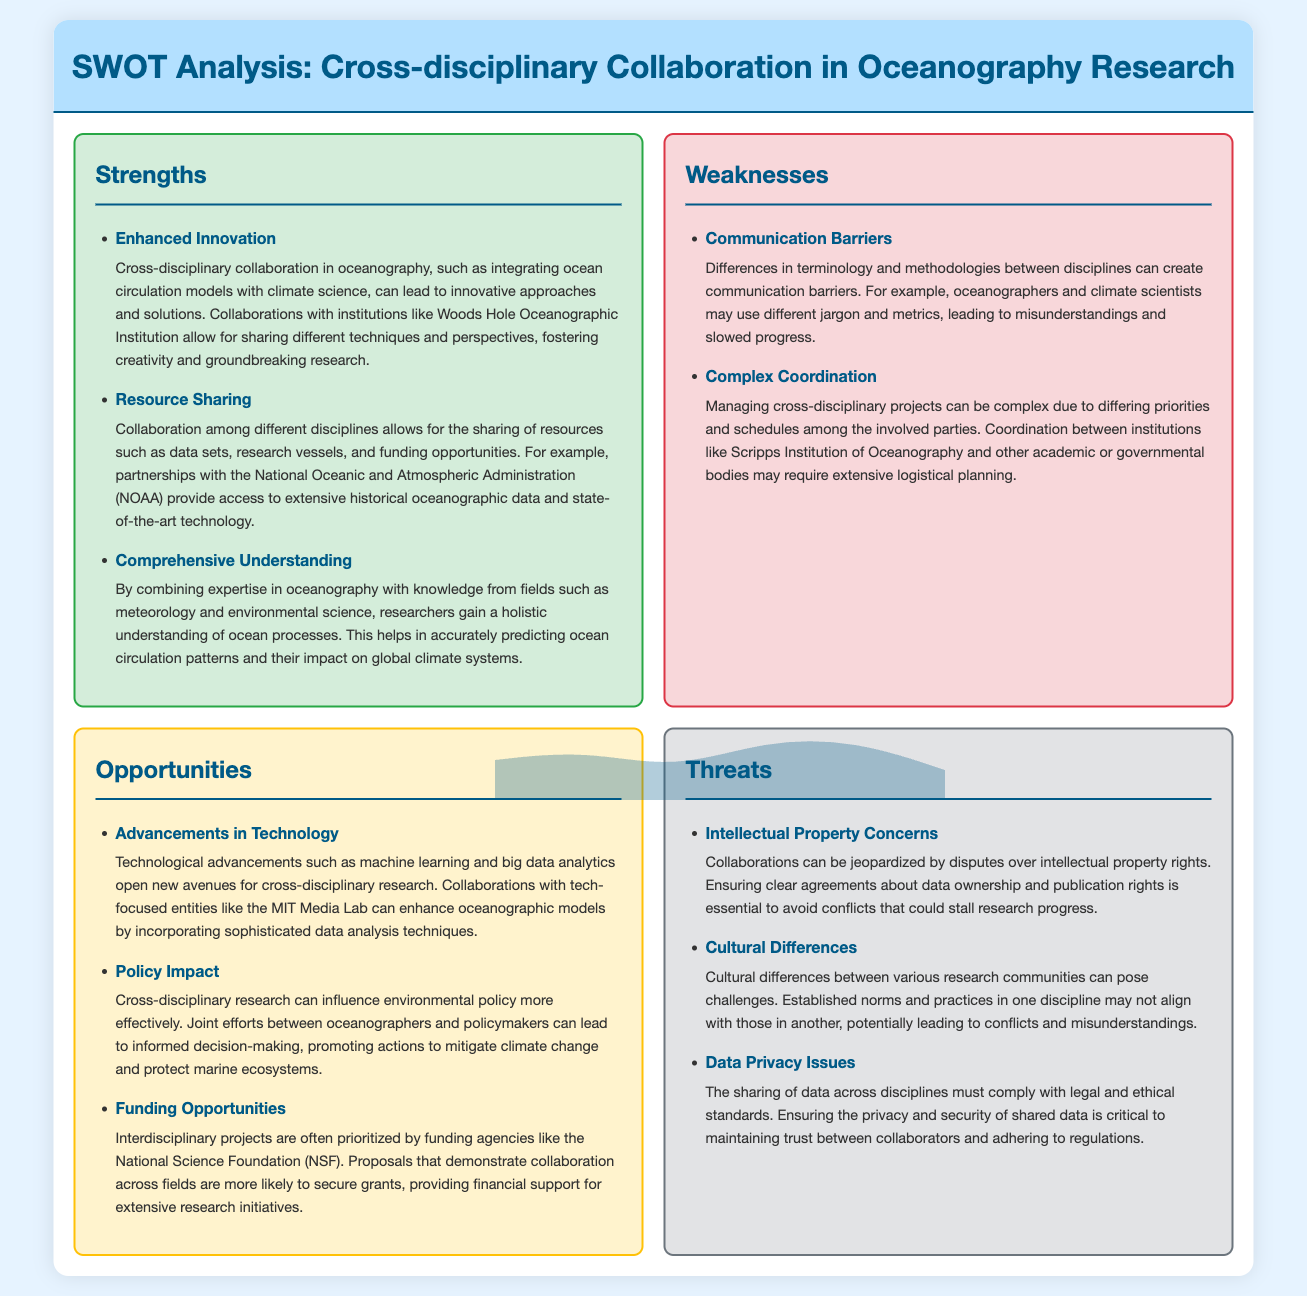what is one strength of cross-disciplinary collaboration in oceanography? The document states that "Enhanced Innovation" is a strength, emphasizing innovative approaches and solutions that arise from collaboration.
Answer: Enhanced Innovation what is a weakness mentioned in the analysis? One weakness highlighted is "Communication Barriers," which discusses how differing terminologies can impede understanding.
Answer: Communication Barriers which institution is mentioned as a collaborator for data sharing? The National Oceanic and Atmospheric Administration (NOAA) is mentioned as a partner providing access to data resources.
Answer: NOAA what is one opportunity for oceanography research through cross-disciplinary collaboration? The document describes "Advancements in Technology" as an opportunity, particularly mentioning machine learning and big data analytics.
Answer: Advancements in Technology what is a threat related to data in cross-disciplinary research? "Data Privacy Issues" is a threat noted in the document, highlighting the importance of compliance with legal standards.
Answer: Data Privacy Issues how many strengths are listed in the SWOT analysis? There are three strengths listed in the analysis that pertain to cross-disciplinary collaboration.
Answer: 3 which two institutions are referenced regarding complex coordination in projects? The document specifically mentions Scripps Institution of Oceanography and other academic or governmental bodies in the context of coordination challenges.
Answer: Scripps Institution of Oceanography what is a potential impact of cross-disciplinary research on environmental policy? The document states that cross-disciplinary research can "influence environmental policy more effectively" by promoting informed decision-making.
Answer: influence environmental policy more effectively what concern can disrupt collaborations according to the analysis? The analysis mentions "Intellectual Property Concerns" as a key issue that can jeopardize partnerships.
Answer: Intellectual Property Concerns 